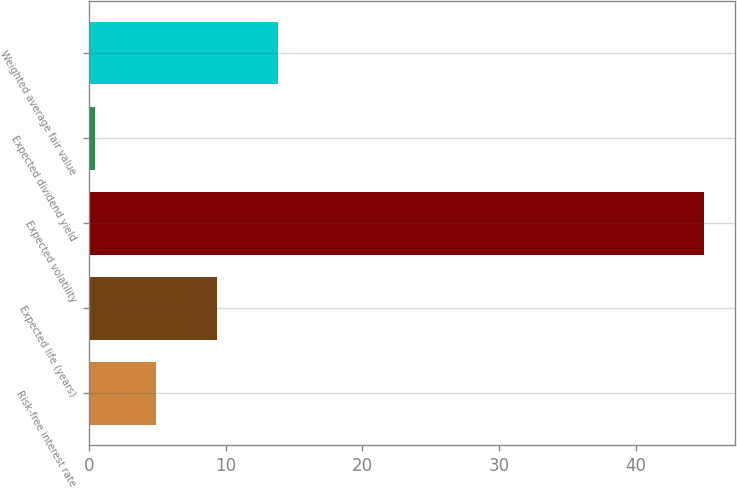Convert chart. <chart><loc_0><loc_0><loc_500><loc_500><bar_chart><fcel>Risk-free interest rate<fcel>Expected life (years)<fcel>Expected volatility<fcel>Expected dividend yield<fcel>Weighted average fair value<nl><fcel>4.88<fcel>9.34<fcel>45<fcel>0.42<fcel>13.8<nl></chart> 